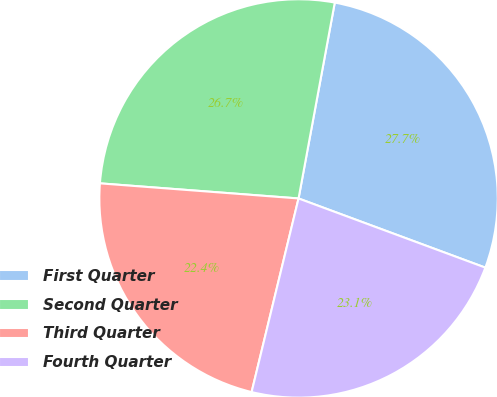Convert chart. <chart><loc_0><loc_0><loc_500><loc_500><pie_chart><fcel>First Quarter<fcel>Second Quarter<fcel>Third Quarter<fcel>Fourth Quarter<nl><fcel>27.73%<fcel>26.7%<fcel>22.42%<fcel>23.14%<nl></chart> 